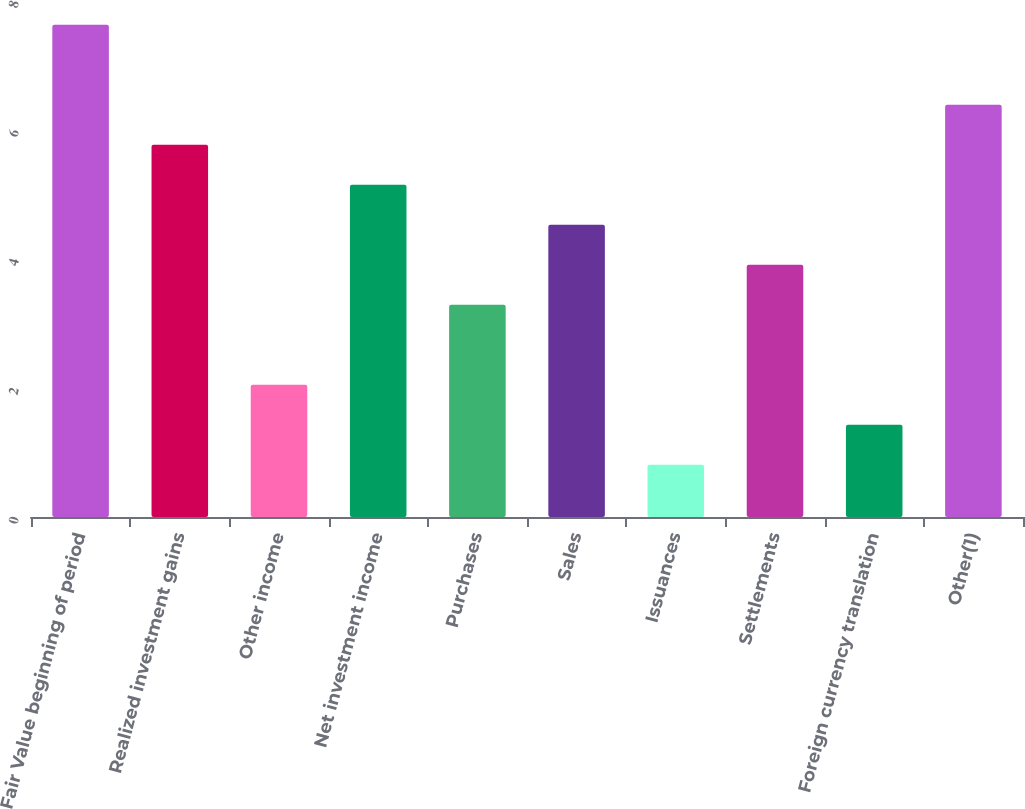Convert chart to OTSL. <chart><loc_0><loc_0><loc_500><loc_500><bar_chart><fcel>Fair Value beginning of period<fcel>Realized investment gains<fcel>Other income<fcel>Net investment income<fcel>Purchases<fcel>Sales<fcel>Issuances<fcel>Settlements<fcel>Foreign currency translation<fcel>Other(1)<nl><fcel>7.63<fcel>5.77<fcel>2.05<fcel>5.15<fcel>3.29<fcel>4.53<fcel>0.81<fcel>3.91<fcel>1.43<fcel>6.39<nl></chart> 